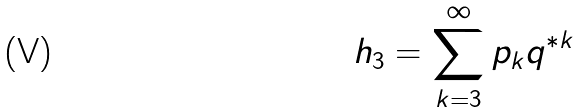Convert formula to latex. <formula><loc_0><loc_0><loc_500><loc_500>h _ { 3 } = \sum _ { k = 3 } ^ { \infty } p _ { k } q ^ { * k }</formula> 